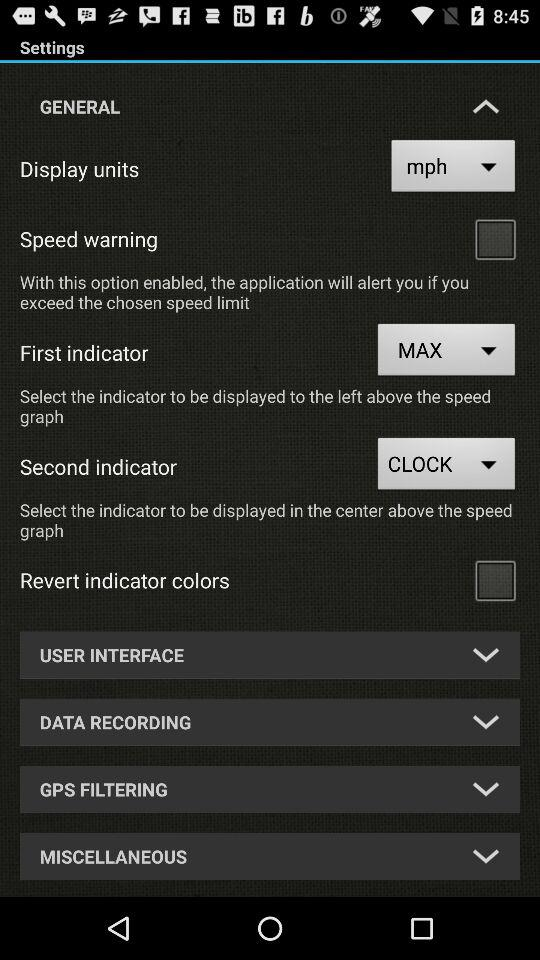What option is selected for the second indicator? The selected option is "CLOCK". 